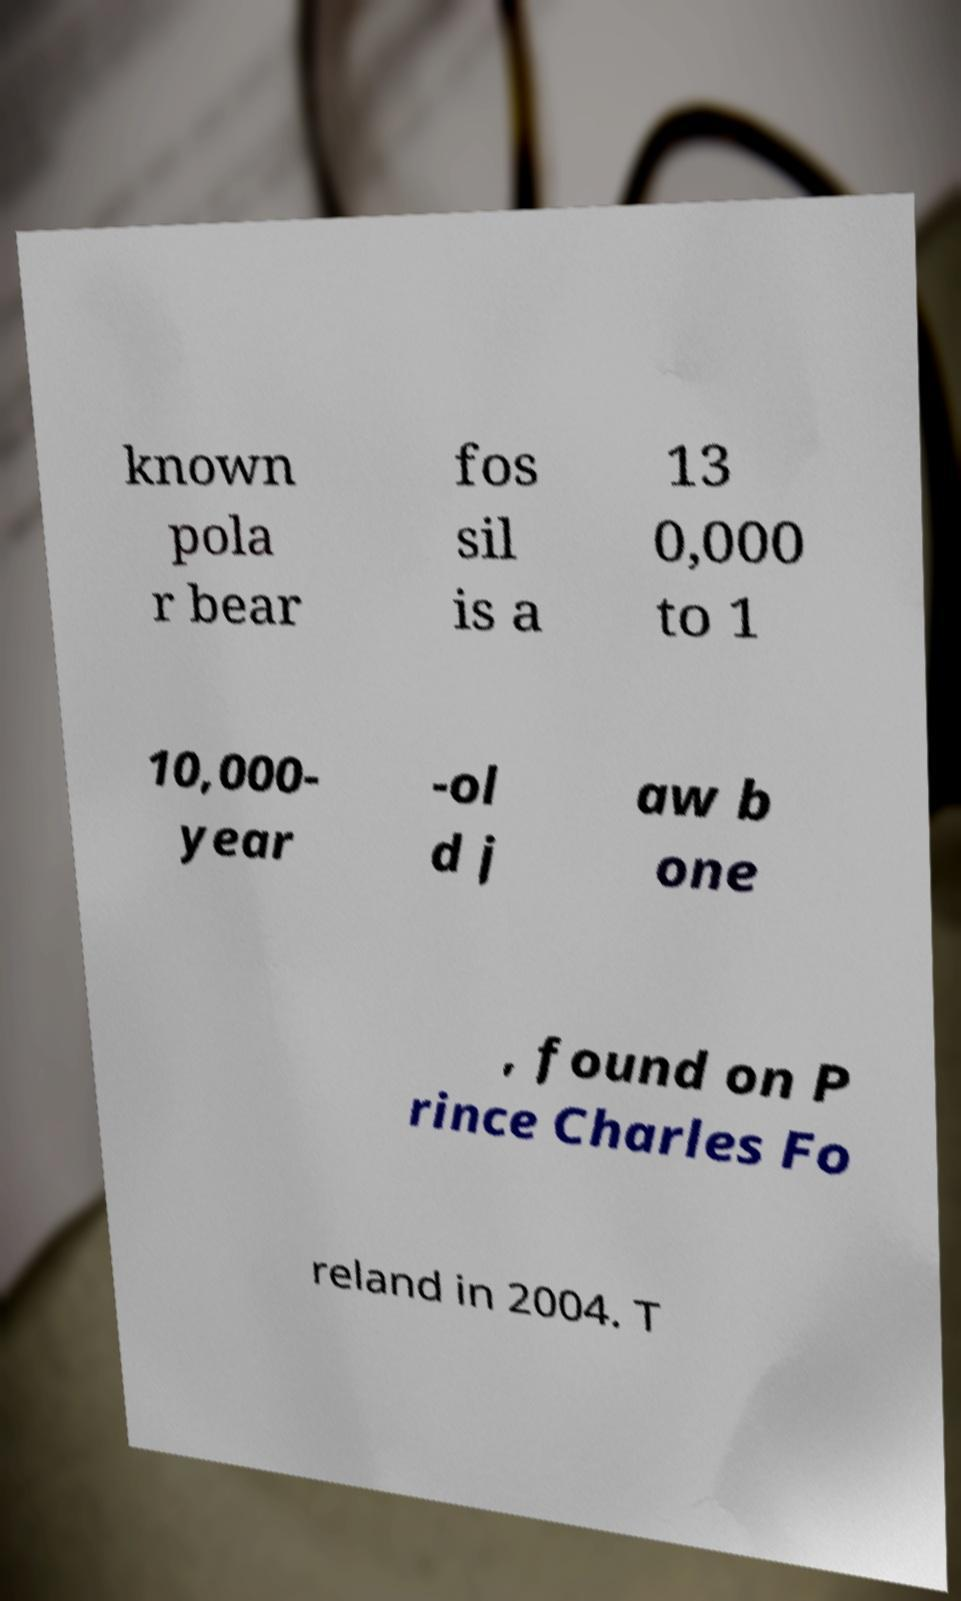For documentation purposes, I need the text within this image transcribed. Could you provide that? known pola r bear fos sil is a 13 0,000 to 1 10,000- year -ol d j aw b one , found on P rince Charles Fo reland in 2004. T 